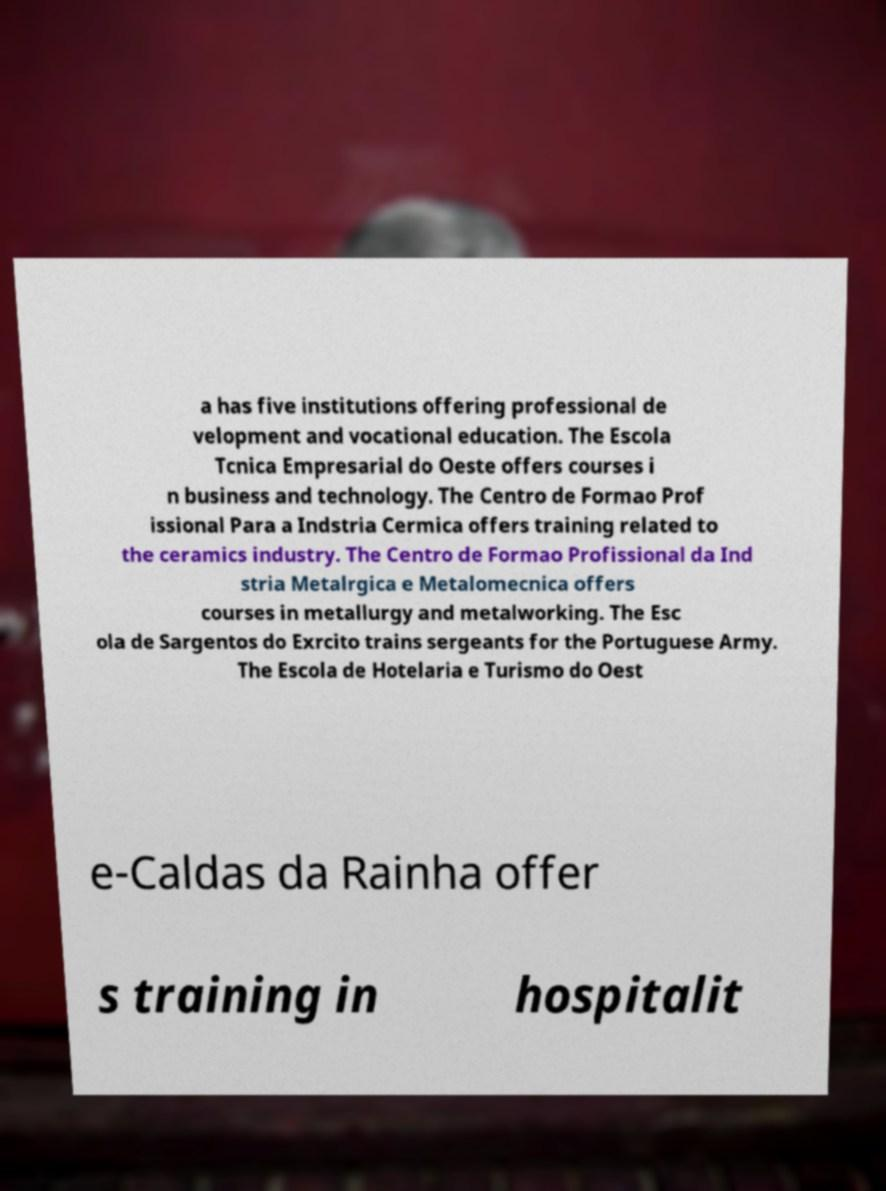Can you accurately transcribe the text from the provided image for me? a has five institutions offering professional de velopment and vocational education. The Escola Tcnica Empresarial do Oeste offers courses i n business and technology. The Centro de Formao Prof issional Para a Indstria Cermica offers training related to the ceramics industry. The Centro de Formao Profissional da Ind stria Metalrgica e Metalomecnica offers courses in metallurgy and metalworking. The Esc ola de Sargentos do Exrcito trains sergeants for the Portuguese Army. The Escola de Hotelaria e Turismo do Oest e-Caldas da Rainha offer s training in hospitalit 